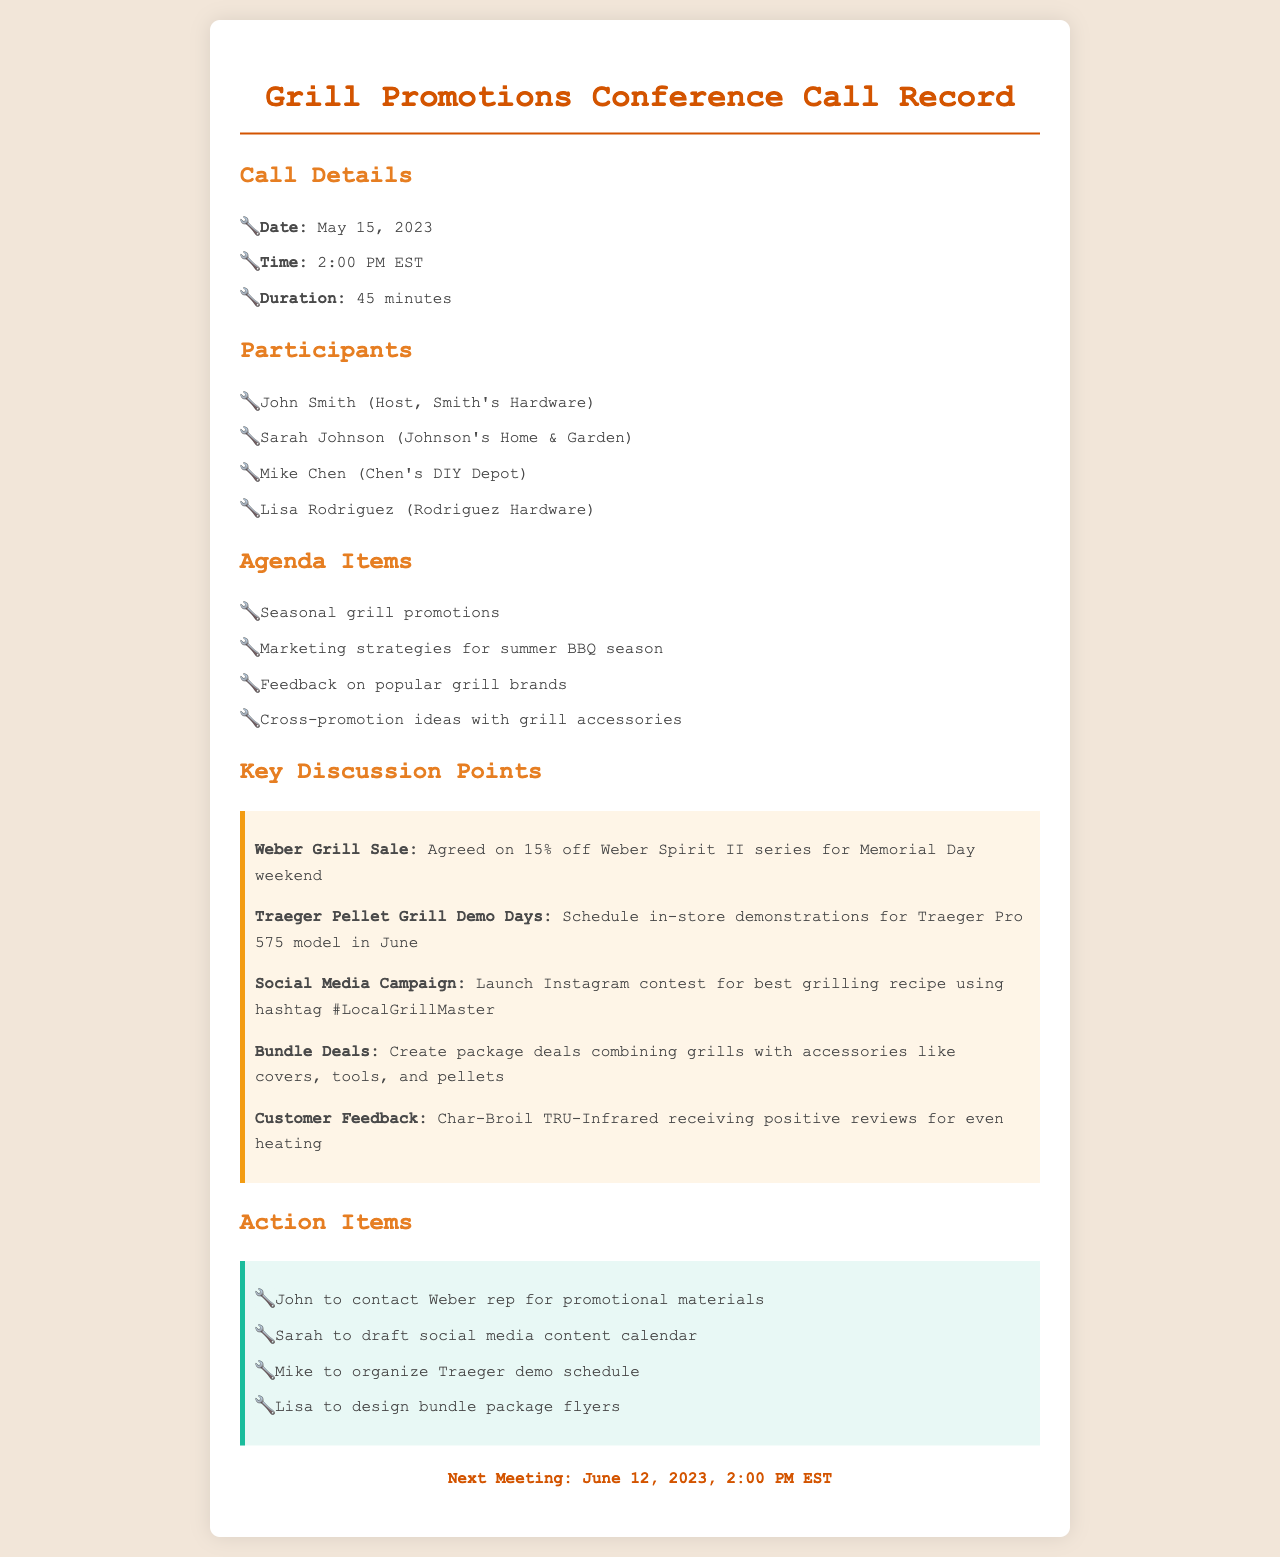What is the date of the conference call? The date of the conference call is mentioned in the call details section.
Answer: May 15, 2023 Who is the host of the call? The host of the call is identified in the participants section.
Answer: John Smith What is the discount on Weber Grill for Memorial Day weekend? The discount is mentioned in the key discussion points section.
Answer: 15% off What model will have in-store demonstrations in June? The specific model for in-store demonstrations is noted in the key discussion points.
Answer: Traeger Pro 575 When is the next meeting scheduled? The date for the next meeting is stated at the end of the document.
Answer: June 12, 2023 What is the main social media campaign hashtag mentioned? The hashtag for the social media campaign is highlighted in the key discussion points.
Answer: #LocalGrillMaster How many participants were in the call? The total number of participants can be counted in the participants section.
Answer: Four What type of feedback was received for Char-Broil TRU-Infrared? The type of feedback is specified in the key discussion points.
Answer: Positive reviews for even heating 